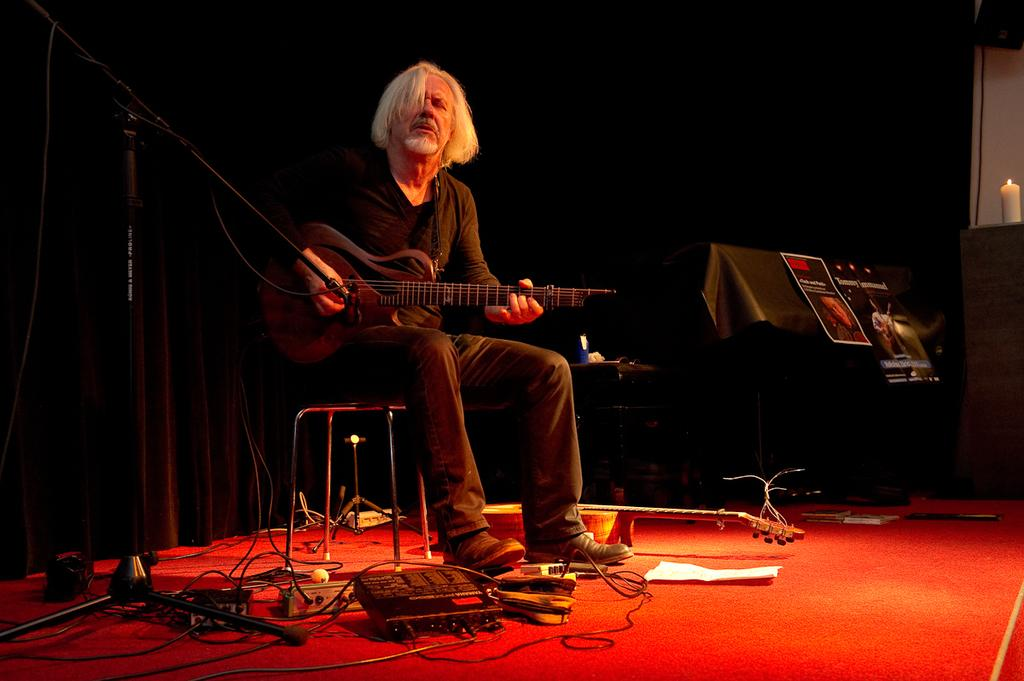What is the person in the image doing? The person is sitting on a chair and playing a guitar. What other objects related to music can be seen in the image? There are musical instruments visible in the image. What device might be used to amplify the sound of the instruments? There is a sound system in the image. Can you see the person's partner in the image? There is no mention of a partner in the image, so we cannot determine if one is present. 